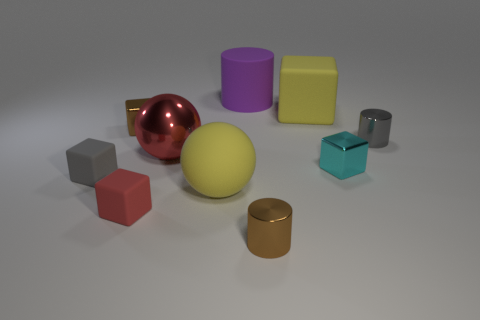Subtract 1 cubes. How many cubes are left? 4 Subtract all tiny red rubber cubes. How many cubes are left? 4 Subtract all cyan blocks. How many blocks are left? 4 Subtract all blue blocks. Subtract all red spheres. How many blocks are left? 5 Subtract all cylinders. How many objects are left? 7 Subtract all large purple matte things. Subtract all tiny metal blocks. How many objects are left? 7 Add 4 cubes. How many cubes are left? 9 Add 4 small yellow metallic spheres. How many small yellow metallic spheres exist? 4 Subtract 0 blue spheres. How many objects are left? 10 